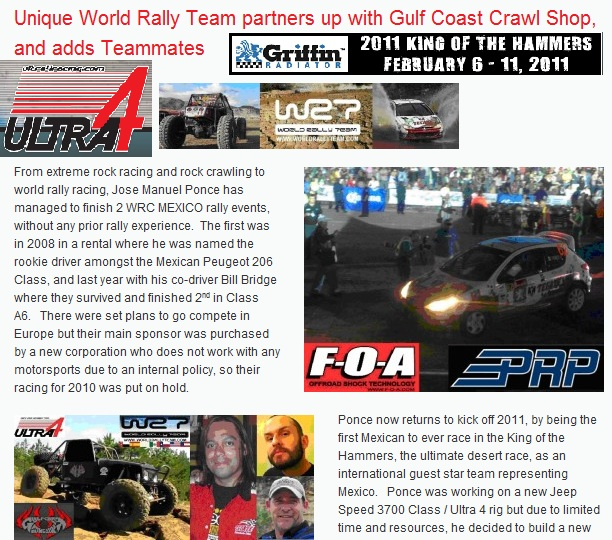Describe a creative scenario where Jose Manuel Ponce's skills are put to the ultimate test in an intergalactic rally. In a not-so-distant future, Jose Manuel Ponce finds himself invited to the inaugural Intergalactic Rally Championship, a racing event spanning various planets and moons in the cosmos. Equipped with a next-generation rally vehicle capable of interplanetary travel, Ponce and his co-driver, Bill Bridge, prepare to face unimaginable terrains – from dune-covered deserts on Mars to ice-laden tracks on Europa, and gravity-defying circuits on space stations orbiting distant stars. Their vehicle, sponsored by an alliance of Earth’s top brands like the Gulf Coast Crawl Shop and ULTRA4, features advanced propulsion systems, adaptive suspension for varied gravity fields, and nanomaterial tires that adjust to the surface type instantly. As they navigate alien landscapes and encounter extraterrestrial competitors, Ponce’s rally skills are pushed to the limit. The duo must rely on their deep bond, quick decision-making, and relentless spirits to claim victory in the galaxy’s most diverse and grueling racing event. 